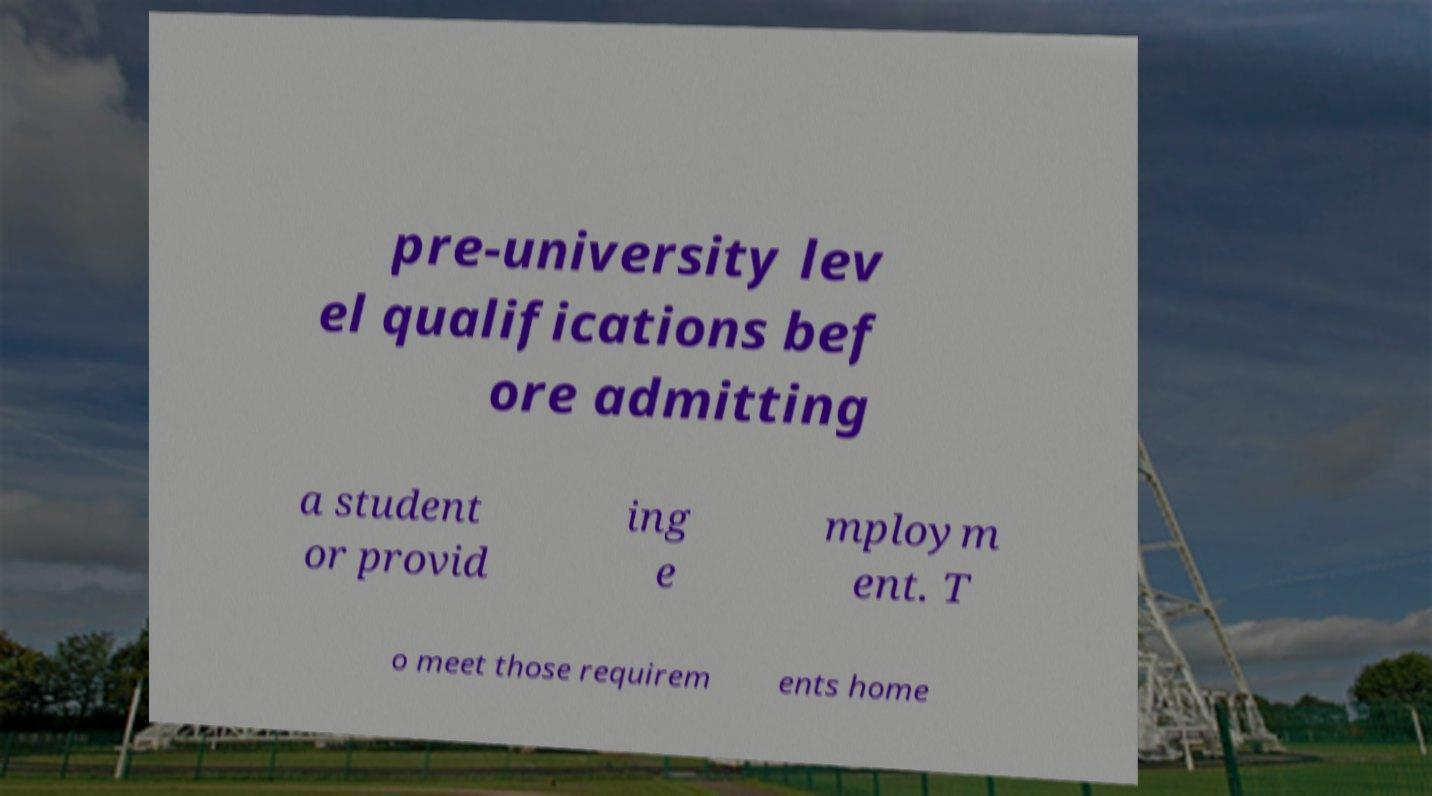I need the written content from this picture converted into text. Can you do that? pre-university lev el qualifications bef ore admitting a student or provid ing e mploym ent. T o meet those requirem ents home 